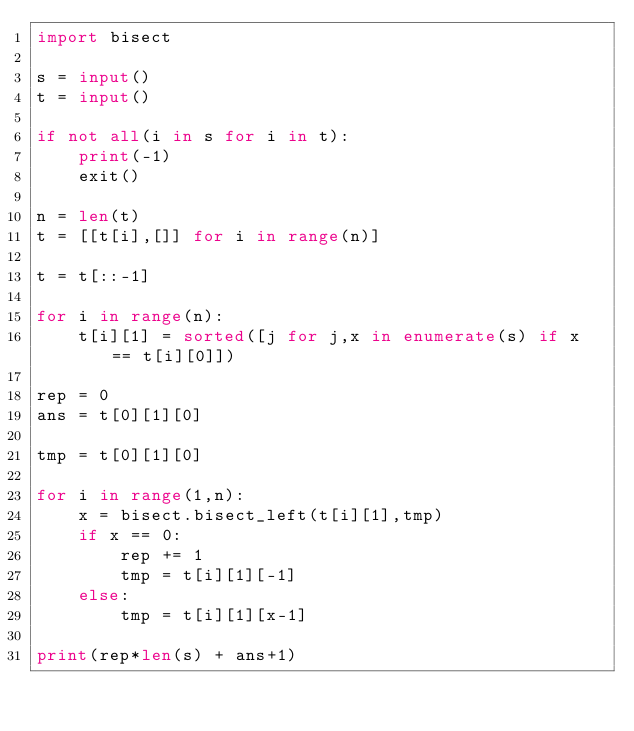<code> <loc_0><loc_0><loc_500><loc_500><_Python_>import bisect

s = input()
t = input()

if not all(i in s for i in t):
    print(-1)
    exit()

n = len(t)
t = [[t[i],[]] for i in range(n)]

t = t[::-1]

for i in range(n):
    t[i][1] = sorted([j for j,x in enumerate(s) if x == t[i][0]])

rep = 0
ans = t[0][1][0]

tmp = t[0][1][0]

for i in range(1,n):
    x = bisect.bisect_left(t[i][1],tmp)
    if x == 0:
        rep += 1
        tmp = t[i][1][-1]
    else:
        tmp = t[i][1][x-1]

print(rep*len(s) + ans+1)
    
    


</code> 